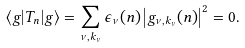<formula> <loc_0><loc_0><loc_500><loc_500>\langle g | T _ { n } | g \rangle = \sum _ { \nu , k _ { \nu } } \epsilon _ { \nu } ( n ) \left | g _ { \nu , k _ { \nu } } ( n ) \right | ^ { 2 } = 0 .</formula> 